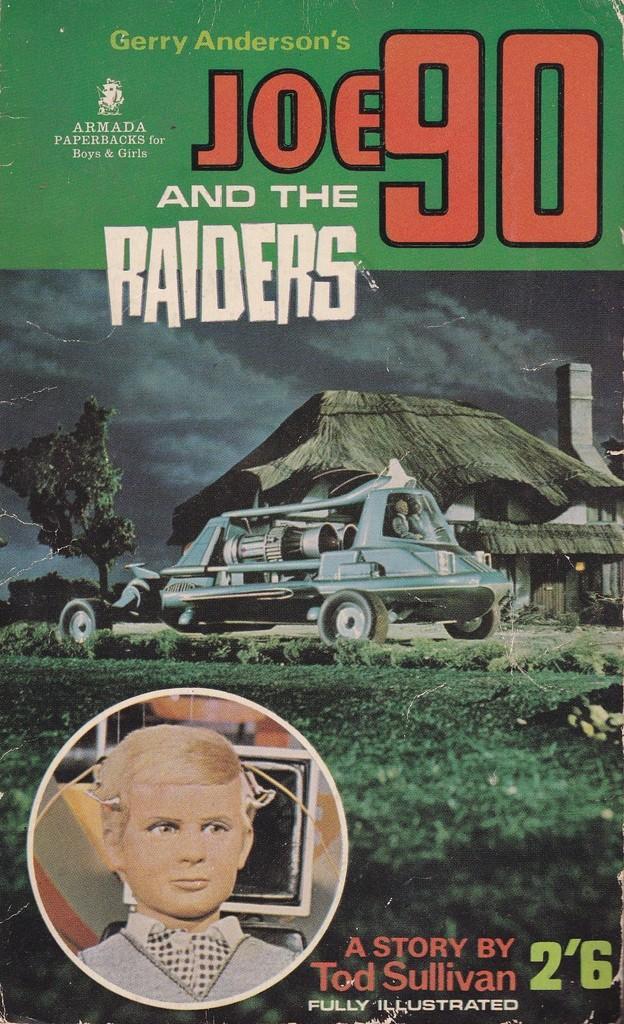Can you describe this image briefly? This image consists of a poster with a text and a few images on it. 